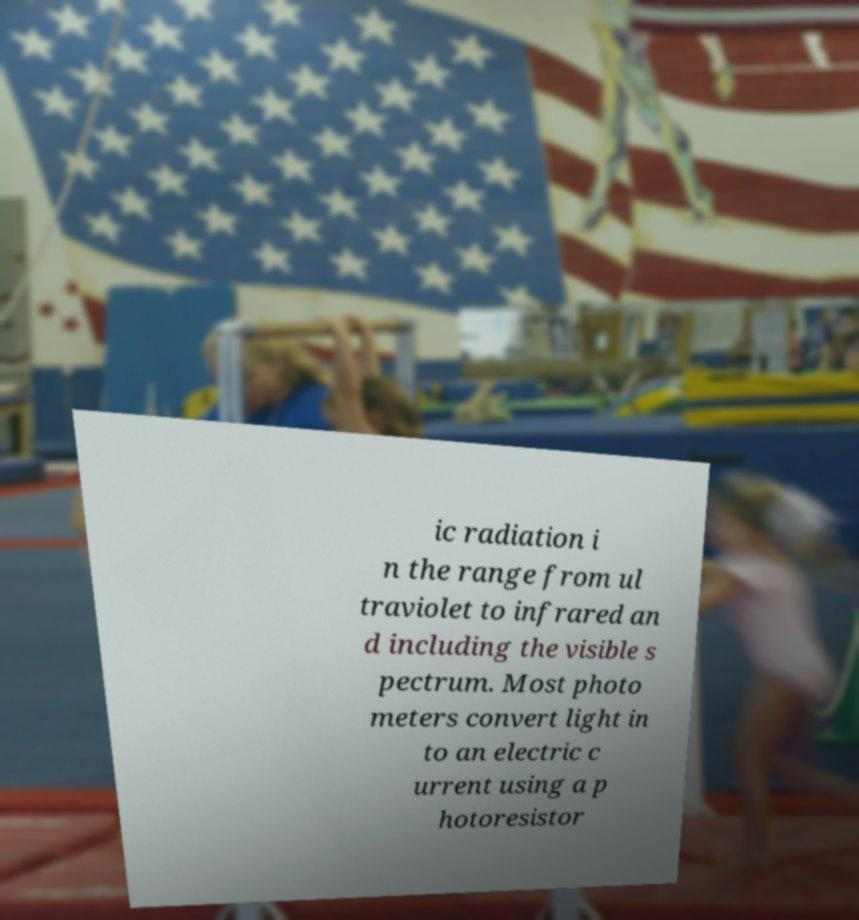Can you read and provide the text displayed in the image?This photo seems to have some interesting text. Can you extract and type it out for me? ic radiation i n the range from ul traviolet to infrared an d including the visible s pectrum. Most photo meters convert light in to an electric c urrent using a p hotoresistor 